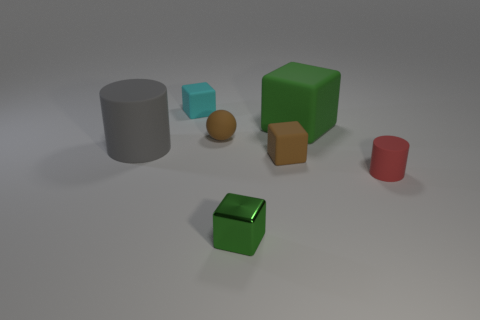Subtract all brown cylinders. How many green blocks are left? 2 Add 3 brown cylinders. How many objects exist? 10 Subtract all large cubes. How many cubes are left? 3 Subtract all cylinders. How many objects are left? 5 Subtract all cyan cubes. How many cubes are left? 3 Add 3 tiny red things. How many tiny red things are left? 4 Add 1 large matte cylinders. How many large matte cylinders exist? 2 Subtract 1 brown cubes. How many objects are left? 6 Subtract all cyan cylinders. Subtract all green balls. How many cylinders are left? 2 Subtract all red cylinders. Subtract all tiny brown things. How many objects are left? 4 